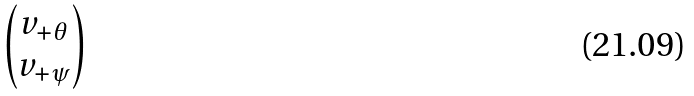<formula> <loc_0><loc_0><loc_500><loc_500>\begin{pmatrix} v _ { + \theta } \\ v _ { + \psi } \end{pmatrix}</formula> 